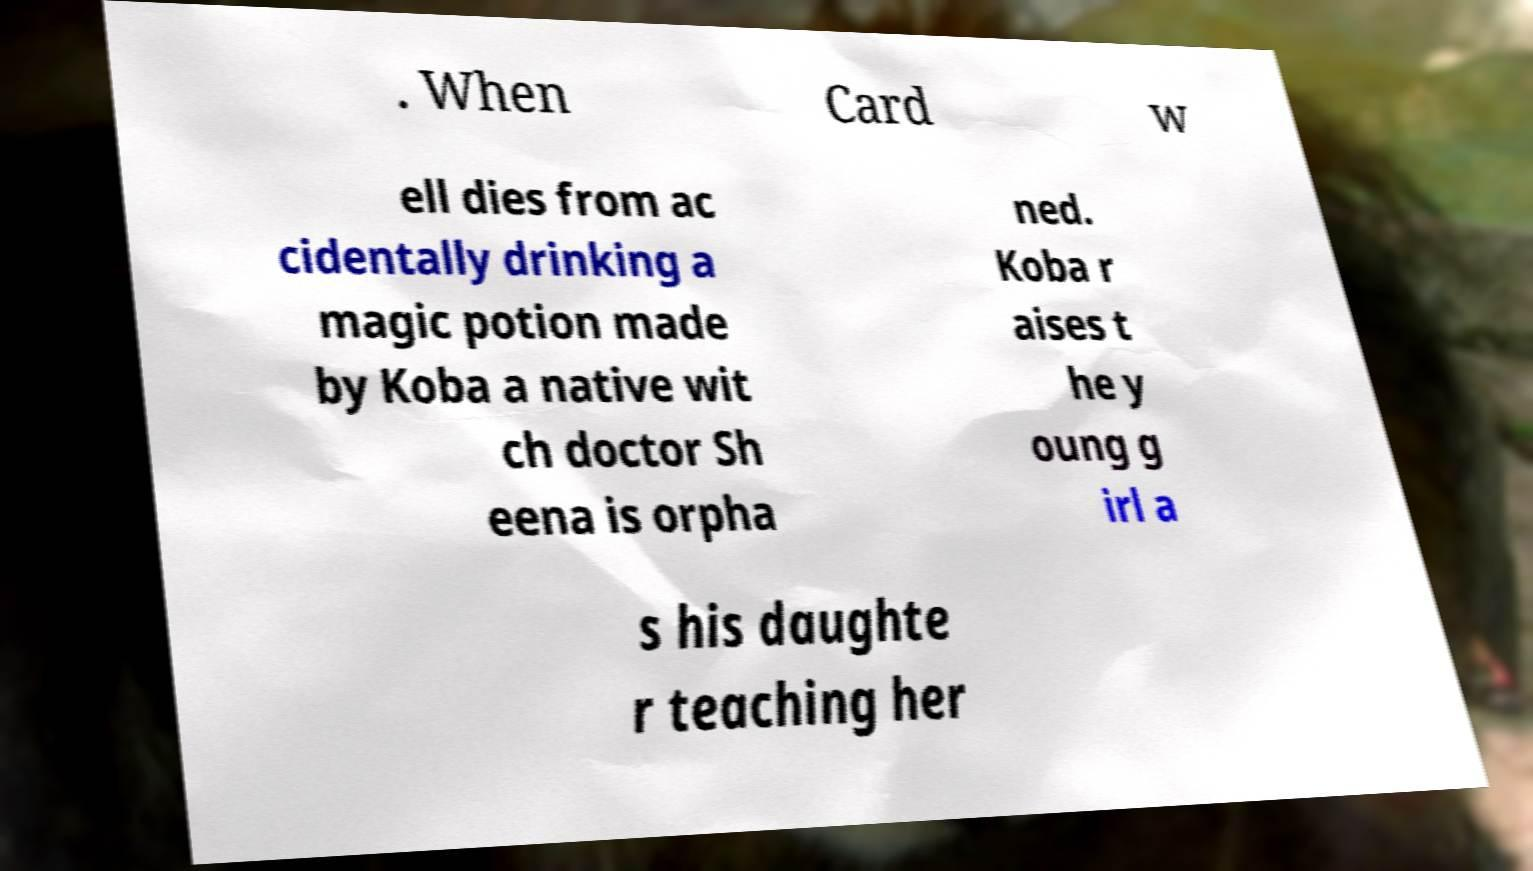Please identify and transcribe the text found in this image. . When Card w ell dies from ac cidentally drinking a magic potion made by Koba a native wit ch doctor Sh eena is orpha ned. Koba r aises t he y oung g irl a s his daughte r teaching her 